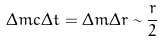<formula> <loc_0><loc_0><loc_500><loc_500>\Delta m c \Delta t = \Delta m \Delta r \sim \frac { r } { 2 }</formula> 